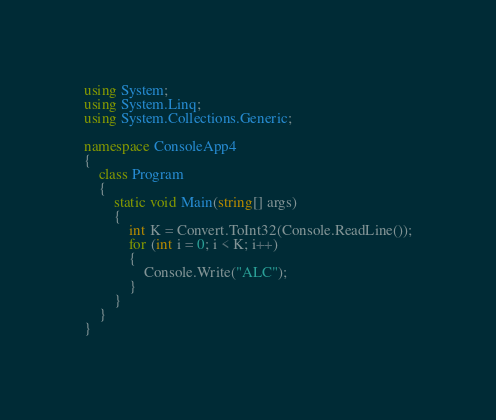<code> <loc_0><loc_0><loc_500><loc_500><_C#_>using System;
using System.Linq;
using System.Collections.Generic;

namespace ConsoleApp4
{
    class Program
    {
        static void Main(string[] args)
        {
            int K = Convert.ToInt32(Console.ReadLine());
            for (int i = 0; i < K; i++)
            {
                Console.Write("ALC");
            }
        }
    }
}</code> 